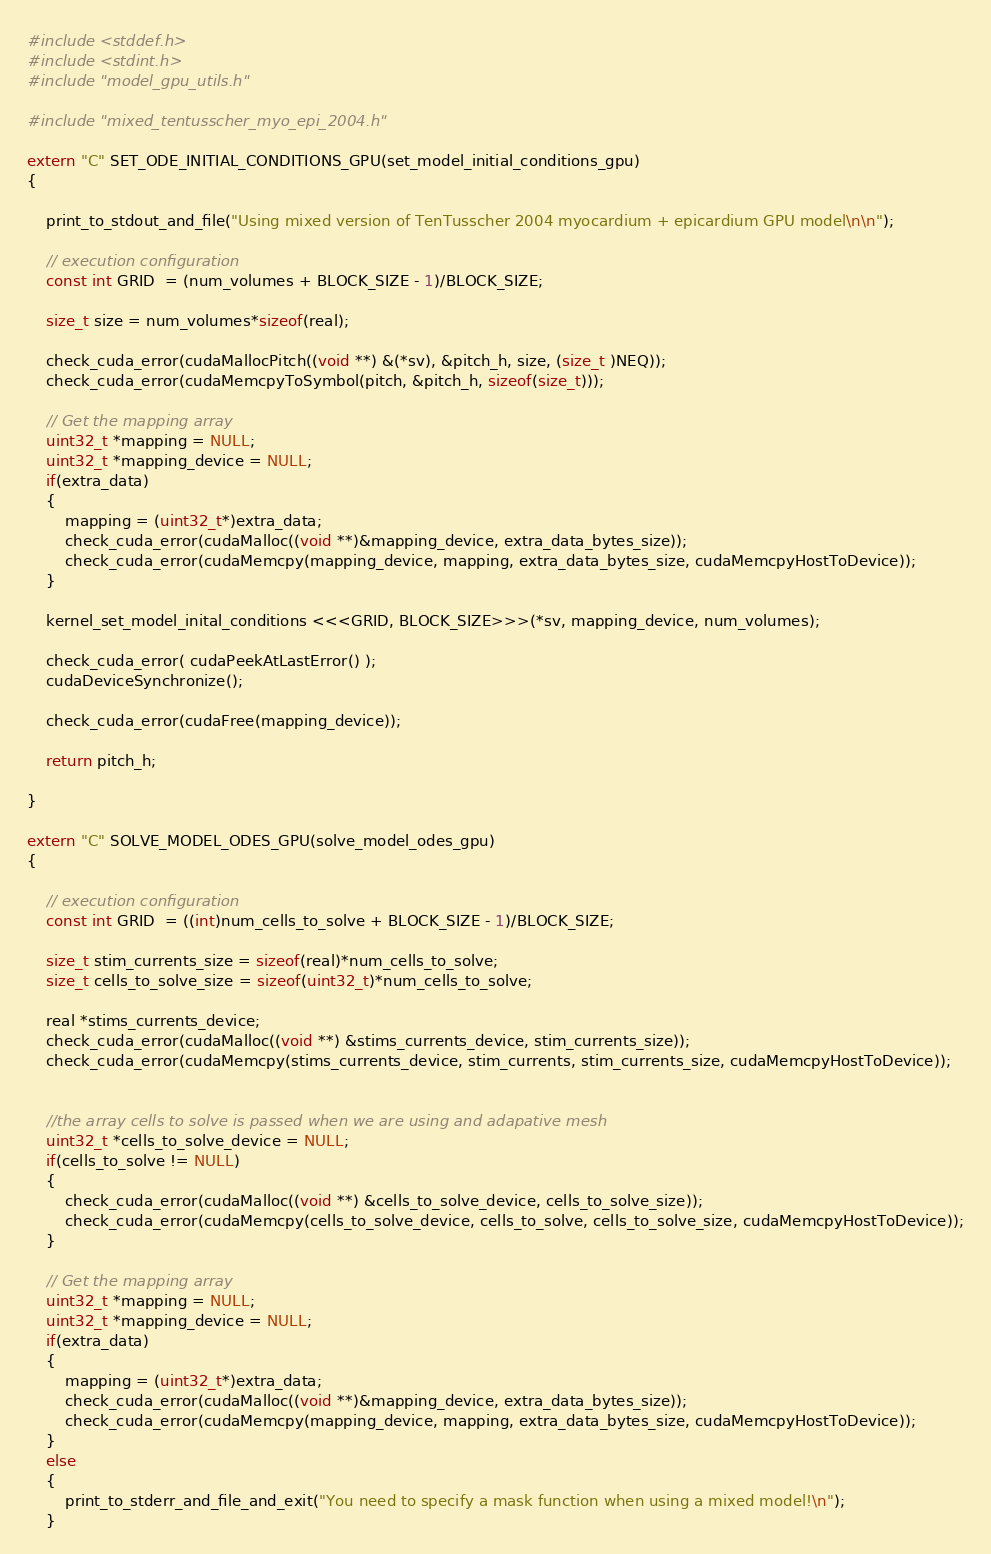<code> <loc_0><loc_0><loc_500><loc_500><_Cuda_>#include <stddef.h>
#include <stdint.h>
#include "model_gpu_utils.h"

#include "mixed_tentusscher_myo_epi_2004.h"

extern "C" SET_ODE_INITIAL_CONDITIONS_GPU(set_model_initial_conditions_gpu) 
{

    print_to_stdout_and_file("Using mixed version of TenTusscher 2004 myocardium + epicardium GPU model\n\n");

    // execution configuration
    const int GRID  = (num_volumes + BLOCK_SIZE - 1)/BLOCK_SIZE;

    size_t size = num_volumes*sizeof(real);

    check_cuda_error(cudaMallocPitch((void **) &(*sv), &pitch_h, size, (size_t )NEQ));
    check_cuda_error(cudaMemcpyToSymbol(pitch, &pitch_h, sizeof(size_t)));

    // Get the mapping array
    uint32_t *mapping = NULL;
    uint32_t *mapping_device = NULL;
    if(extra_data) 
    {
        mapping = (uint32_t*)extra_data;
        check_cuda_error(cudaMalloc((void **)&mapping_device, extra_data_bytes_size));
        check_cuda_error(cudaMemcpy(mapping_device, mapping, extra_data_bytes_size, cudaMemcpyHostToDevice));
    }

    kernel_set_model_inital_conditions <<<GRID, BLOCK_SIZE>>>(*sv, mapping_device, num_volumes);

    check_cuda_error( cudaPeekAtLastError() );
    cudaDeviceSynchronize();
    
    check_cuda_error(cudaFree(mapping_device));

    return pitch_h;

}

extern "C" SOLVE_MODEL_ODES_GPU(solve_model_odes_gpu) 
{

    // execution configuration
    const int GRID  = ((int)num_cells_to_solve + BLOCK_SIZE - 1)/BLOCK_SIZE;

    size_t stim_currents_size = sizeof(real)*num_cells_to_solve;
    size_t cells_to_solve_size = sizeof(uint32_t)*num_cells_to_solve;

    real *stims_currents_device;
    check_cuda_error(cudaMalloc((void **) &stims_currents_device, stim_currents_size));
    check_cuda_error(cudaMemcpy(stims_currents_device, stim_currents, stim_currents_size, cudaMemcpyHostToDevice));


    //the array cells to solve is passed when we are using and adapative mesh
    uint32_t *cells_to_solve_device = NULL;
    if(cells_to_solve != NULL) 
    {
        check_cuda_error(cudaMalloc((void **) &cells_to_solve_device, cells_to_solve_size));
        check_cuda_error(cudaMemcpy(cells_to_solve_device, cells_to_solve, cells_to_solve_size, cudaMemcpyHostToDevice));
    }

    // Get the mapping array
    uint32_t *mapping = NULL;
    uint32_t *mapping_device = NULL;
    if(extra_data) 
    {
        mapping = (uint32_t*)extra_data;
        check_cuda_error(cudaMalloc((void **)&mapping_device, extra_data_bytes_size));
        check_cuda_error(cudaMemcpy(mapping_device, mapping, extra_data_bytes_size, cudaMemcpyHostToDevice));
    }
    else 
    {
        print_to_stderr_and_file_and_exit("You need to specify a mask function when using a mixed model!\n");
    }
</code> 